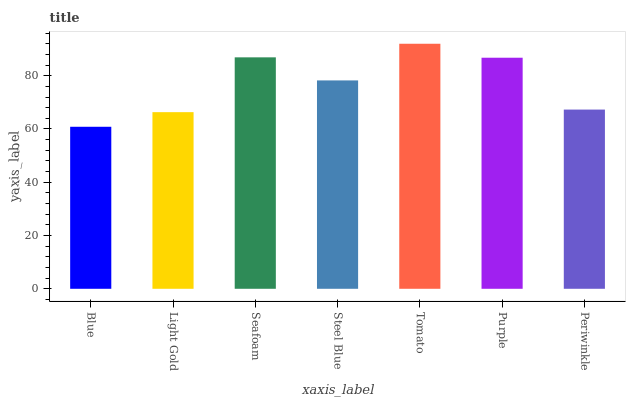Is Blue the minimum?
Answer yes or no. Yes. Is Tomato the maximum?
Answer yes or no. Yes. Is Light Gold the minimum?
Answer yes or no. No. Is Light Gold the maximum?
Answer yes or no. No. Is Light Gold greater than Blue?
Answer yes or no. Yes. Is Blue less than Light Gold?
Answer yes or no. Yes. Is Blue greater than Light Gold?
Answer yes or no. No. Is Light Gold less than Blue?
Answer yes or no. No. Is Steel Blue the high median?
Answer yes or no. Yes. Is Steel Blue the low median?
Answer yes or no. Yes. Is Tomato the high median?
Answer yes or no. No. Is Tomato the low median?
Answer yes or no. No. 